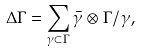<formula> <loc_0><loc_0><loc_500><loc_500>\Delta \Gamma = \sum _ { \gamma \subset \Gamma } \bar { \gamma } \otimes \Gamma / \gamma ,</formula> 